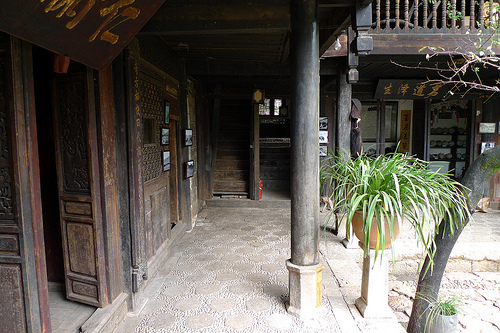<image>
Is the door next to the plant? Yes. The door is positioned adjacent to the plant, located nearby in the same general area. Is the column next to the plant? Yes. The column is positioned adjacent to the plant, located nearby in the same general area. Where is the pot in relation to the ground? Is it on the ground? No. The pot is not positioned on the ground. They may be near each other, but the pot is not supported by or resting on top of the ground. 